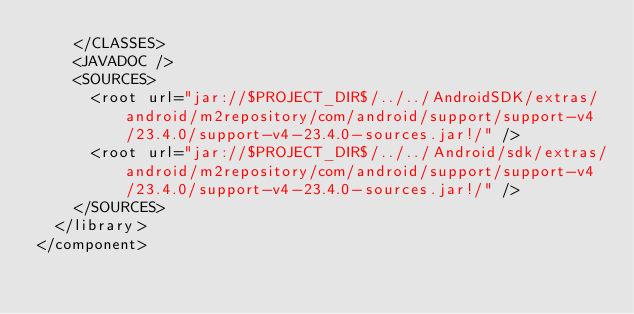<code> <loc_0><loc_0><loc_500><loc_500><_XML_>    </CLASSES>
    <JAVADOC />
    <SOURCES>
      <root url="jar://$PROJECT_DIR$/../../AndroidSDK/extras/android/m2repository/com/android/support/support-v4/23.4.0/support-v4-23.4.0-sources.jar!/" />
      <root url="jar://$PROJECT_DIR$/../../Android/sdk/extras/android/m2repository/com/android/support/support-v4/23.4.0/support-v4-23.4.0-sources.jar!/" />
    </SOURCES>
  </library>
</component></code> 